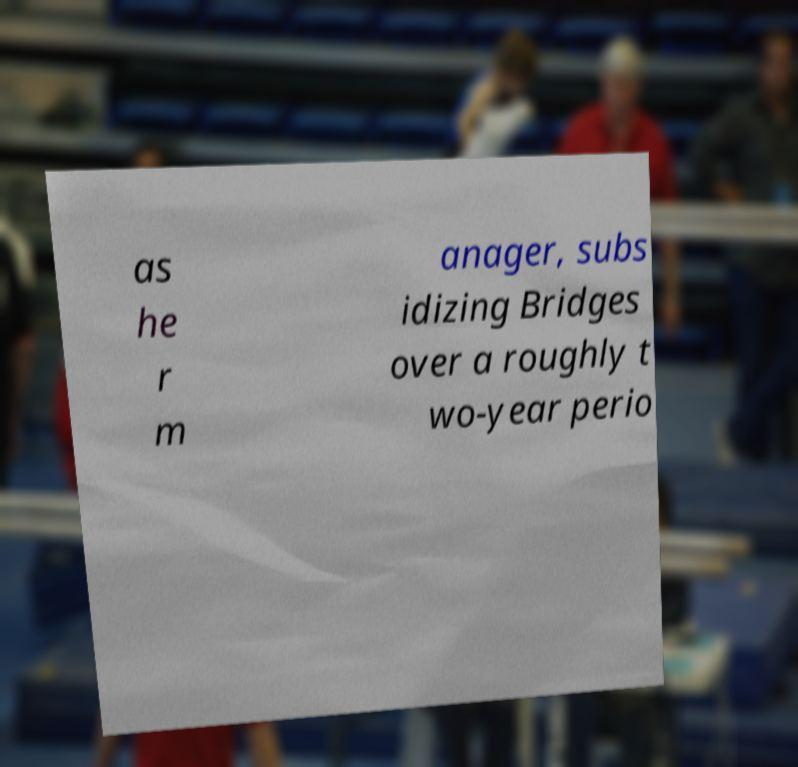For documentation purposes, I need the text within this image transcribed. Could you provide that? as he r m anager, subs idizing Bridges over a roughly t wo-year perio 